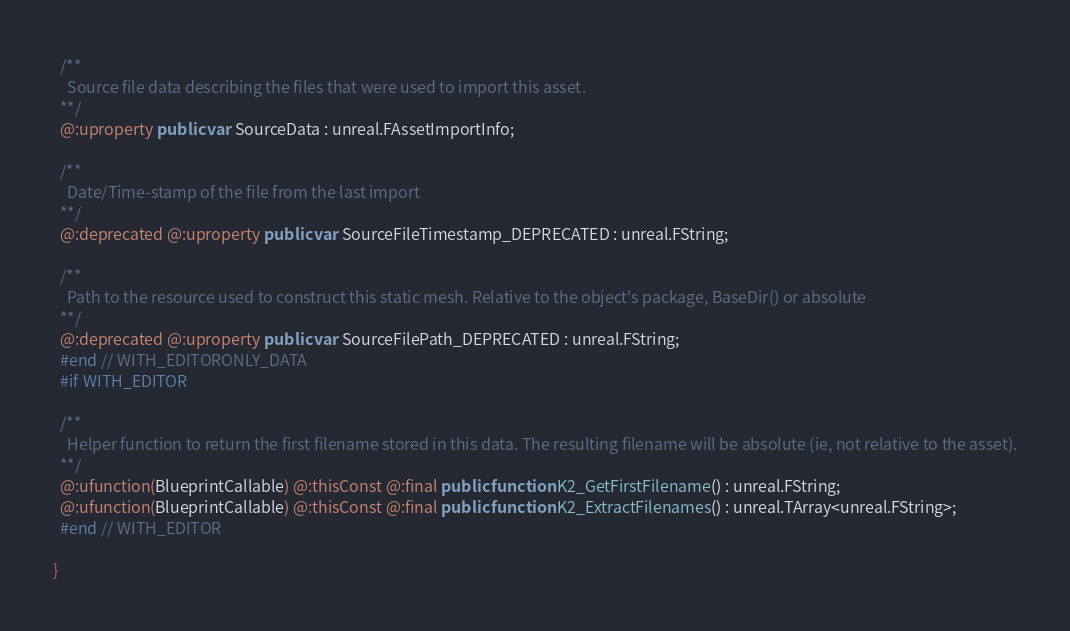Convert code to text. <code><loc_0><loc_0><loc_500><loc_500><_Haxe_>  /**
    Source file data describing the files that were used to import this asset.
  **/
  @:uproperty public var SourceData : unreal.FAssetImportInfo;
  
  /**
    Date/Time-stamp of the file from the last import
  **/
  @:deprecated @:uproperty public var SourceFileTimestamp_DEPRECATED : unreal.FString;
  
  /**
    Path to the resource used to construct this static mesh. Relative to the object's package, BaseDir() or absolute
  **/
  @:deprecated @:uproperty public var SourceFilePath_DEPRECATED : unreal.FString;
  #end // WITH_EDITORONLY_DATA
  #if WITH_EDITOR
  
  /**
    Helper function to return the first filename stored in this data. The resulting filename will be absolute (ie, not relative to the asset).
  **/
  @:ufunction(BlueprintCallable) @:thisConst @:final public function K2_GetFirstFilename() : unreal.FString;
  @:ufunction(BlueprintCallable) @:thisConst @:final public function K2_ExtractFilenames() : unreal.TArray<unreal.FString>;
  #end // WITH_EDITOR
  
}
</code> 